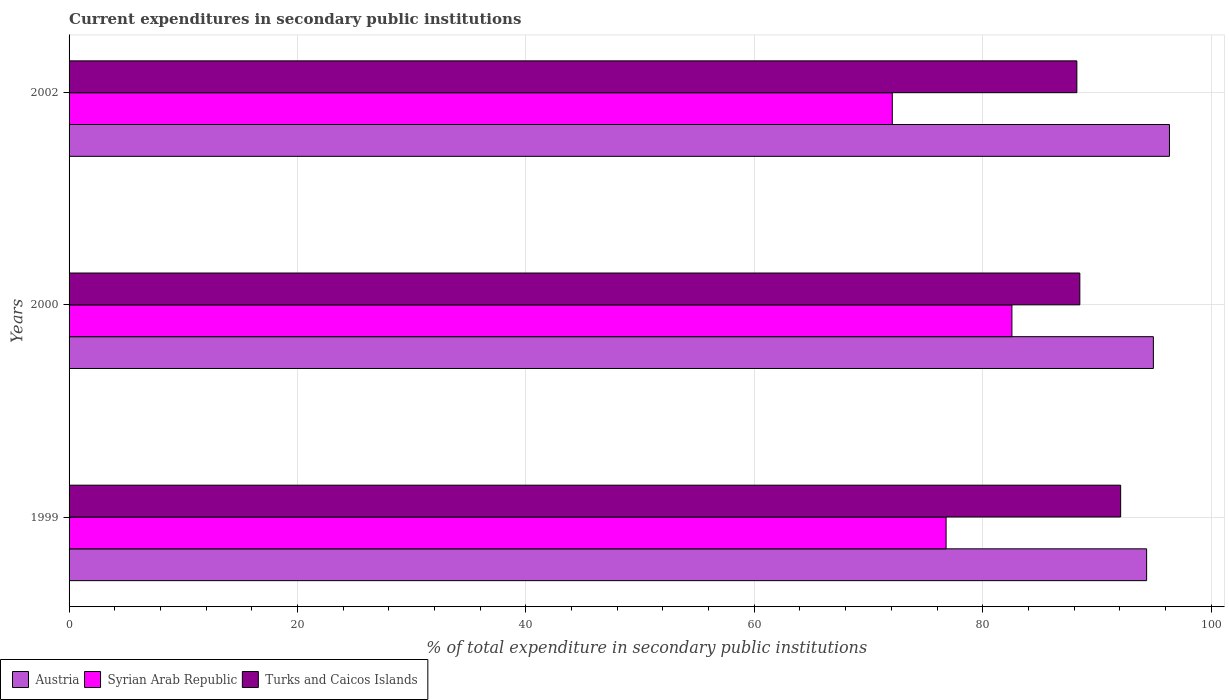How many different coloured bars are there?
Give a very brief answer. 3. How many groups of bars are there?
Make the answer very short. 3. Are the number of bars per tick equal to the number of legend labels?
Offer a very short reply. Yes. How many bars are there on the 3rd tick from the bottom?
Provide a short and direct response. 3. In how many cases, is the number of bars for a given year not equal to the number of legend labels?
Offer a terse response. 0. What is the current expenditures in secondary public institutions in Syrian Arab Republic in 2002?
Make the answer very short. 72.08. Across all years, what is the maximum current expenditures in secondary public institutions in Syrian Arab Republic?
Your answer should be compact. 82.56. Across all years, what is the minimum current expenditures in secondary public institutions in Turks and Caicos Islands?
Keep it short and to the point. 88.24. In which year was the current expenditures in secondary public institutions in Syrian Arab Republic maximum?
Your response must be concise. 2000. In which year was the current expenditures in secondary public institutions in Syrian Arab Republic minimum?
Offer a terse response. 2002. What is the total current expenditures in secondary public institutions in Austria in the graph?
Your response must be concise. 285.65. What is the difference between the current expenditures in secondary public institutions in Syrian Arab Republic in 1999 and that in 2000?
Make the answer very short. -5.76. What is the difference between the current expenditures in secondary public institutions in Turks and Caicos Islands in 2000 and the current expenditures in secondary public institutions in Syrian Arab Republic in 1999?
Ensure brevity in your answer.  11.71. What is the average current expenditures in secondary public institutions in Austria per year?
Give a very brief answer. 95.22. In the year 1999, what is the difference between the current expenditures in secondary public institutions in Syrian Arab Republic and current expenditures in secondary public institutions in Austria?
Keep it short and to the point. -17.56. In how many years, is the current expenditures in secondary public institutions in Austria greater than 84 %?
Ensure brevity in your answer.  3. What is the ratio of the current expenditures in secondary public institutions in Austria in 2000 to that in 2002?
Your answer should be very brief. 0.99. What is the difference between the highest and the second highest current expenditures in secondary public institutions in Syrian Arab Republic?
Your answer should be compact. 5.76. What is the difference between the highest and the lowest current expenditures in secondary public institutions in Austria?
Give a very brief answer. 2. In how many years, is the current expenditures in secondary public institutions in Syrian Arab Republic greater than the average current expenditures in secondary public institutions in Syrian Arab Republic taken over all years?
Your answer should be compact. 1. What does the 3rd bar from the bottom in 2000 represents?
Keep it short and to the point. Turks and Caicos Islands. Are all the bars in the graph horizontal?
Your answer should be compact. Yes. How many years are there in the graph?
Ensure brevity in your answer.  3. Are the values on the major ticks of X-axis written in scientific E-notation?
Offer a very short reply. No. Does the graph contain any zero values?
Make the answer very short. No. How many legend labels are there?
Offer a terse response. 3. How are the legend labels stacked?
Make the answer very short. Horizontal. What is the title of the graph?
Give a very brief answer. Current expenditures in secondary public institutions. What is the label or title of the X-axis?
Provide a succinct answer. % of total expenditure in secondary public institutions. What is the % of total expenditure in secondary public institutions of Austria in 1999?
Ensure brevity in your answer.  94.35. What is the % of total expenditure in secondary public institutions in Syrian Arab Republic in 1999?
Your response must be concise. 76.79. What is the % of total expenditure in secondary public institutions of Turks and Caicos Islands in 1999?
Give a very brief answer. 92.08. What is the % of total expenditure in secondary public institutions in Austria in 2000?
Your response must be concise. 94.94. What is the % of total expenditure in secondary public institutions of Syrian Arab Republic in 2000?
Offer a very short reply. 82.56. What is the % of total expenditure in secondary public institutions in Turks and Caicos Islands in 2000?
Give a very brief answer. 88.5. What is the % of total expenditure in secondary public institutions in Austria in 2002?
Offer a very short reply. 96.35. What is the % of total expenditure in secondary public institutions in Syrian Arab Republic in 2002?
Provide a short and direct response. 72.08. What is the % of total expenditure in secondary public institutions in Turks and Caicos Islands in 2002?
Offer a very short reply. 88.24. Across all years, what is the maximum % of total expenditure in secondary public institutions in Austria?
Provide a short and direct response. 96.35. Across all years, what is the maximum % of total expenditure in secondary public institutions in Syrian Arab Republic?
Ensure brevity in your answer.  82.56. Across all years, what is the maximum % of total expenditure in secondary public institutions in Turks and Caicos Islands?
Provide a short and direct response. 92.08. Across all years, what is the minimum % of total expenditure in secondary public institutions of Austria?
Provide a succinct answer. 94.35. Across all years, what is the minimum % of total expenditure in secondary public institutions of Syrian Arab Republic?
Keep it short and to the point. 72.08. Across all years, what is the minimum % of total expenditure in secondary public institutions of Turks and Caicos Islands?
Offer a terse response. 88.24. What is the total % of total expenditure in secondary public institutions in Austria in the graph?
Offer a terse response. 285.65. What is the total % of total expenditure in secondary public institutions in Syrian Arab Republic in the graph?
Offer a terse response. 231.43. What is the total % of total expenditure in secondary public institutions of Turks and Caicos Islands in the graph?
Offer a terse response. 268.82. What is the difference between the % of total expenditure in secondary public institutions in Austria in 1999 and that in 2000?
Ensure brevity in your answer.  -0.59. What is the difference between the % of total expenditure in secondary public institutions in Syrian Arab Republic in 1999 and that in 2000?
Give a very brief answer. -5.76. What is the difference between the % of total expenditure in secondary public institutions of Turks and Caicos Islands in 1999 and that in 2000?
Provide a succinct answer. 3.57. What is the difference between the % of total expenditure in secondary public institutions of Austria in 1999 and that in 2002?
Keep it short and to the point. -2. What is the difference between the % of total expenditure in secondary public institutions in Syrian Arab Republic in 1999 and that in 2002?
Give a very brief answer. 4.71. What is the difference between the % of total expenditure in secondary public institutions of Turks and Caicos Islands in 1999 and that in 2002?
Offer a terse response. 3.83. What is the difference between the % of total expenditure in secondary public institutions of Austria in 2000 and that in 2002?
Make the answer very short. -1.41. What is the difference between the % of total expenditure in secondary public institutions of Syrian Arab Republic in 2000 and that in 2002?
Ensure brevity in your answer.  10.48. What is the difference between the % of total expenditure in secondary public institutions of Turks and Caicos Islands in 2000 and that in 2002?
Ensure brevity in your answer.  0.26. What is the difference between the % of total expenditure in secondary public institutions of Austria in 1999 and the % of total expenditure in secondary public institutions of Syrian Arab Republic in 2000?
Give a very brief answer. 11.79. What is the difference between the % of total expenditure in secondary public institutions of Austria in 1999 and the % of total expenditure in secondary public institutions of Turks and Caicos Islands in 2000?
Your response must be concise. 5.85. What is the difference between the % of total expenditure in secondary public institutions in Syrian Arab Republic in 1999 and the % of total expenditure in secondary public institutions in Turks and Caicos Islands in 2000?
Your answer should be very brief. -11.71. What is the difference between the % of total expenditure in secondary public institutions of Austria in 1999 and the % of total expenditure in secondary public institutions of Syrian Arab Republic in 2002?
Offer a terse response. 22.27. What is the difference between the % of total expenditure in secondary public institutions in Austria in 1999 and the % of total expenditure in secondary public institutions in Turks and Caicos Islands in 2002?
Provide a succinct answer. 6.11. What is the difference between the % of total expenditure in secondary public institutions in Syrian Arab Republic in 1999 and the % of total expenditure in secondary public institutions in Turks and Caicos Islands in 2002?
Keep it short and to the point. -11.45. What is the difference between the % of total expenditure in secondary public institutions in Austria in 2000 and the % of total expenditure in secondary public institutions in Syrian Arab Republic in 2002?
Make the answer very short. 22.86. What is the difference between the % of total expenditure in secondary public institutions in Austria in 2000 and the % of total expenditure in secondary public institutions in Turks and Caicos Islands in 2002?
Give a very brief answer. 6.7. What is the difference between the % of total expenditure in secondary public institutions of Syrian Arab Republic in 2000 and the % of total expenditure in secondary public institutions of Turks and Caicos Islands in 2002?
Make the answer very short. -5.69. What is the average % of total expenditure in secondary public institutions in Austria per year?
Your response must be concise. 95.22. What is the average % of total expenditure in secondary public institutions of Syrian Arab Republic per year?
Keep it short and to the point. 77.14. What is the average % of total expenditure in secondary public institutions in Turks and Caicos Islands per year?
Provide a short and direct response. 89.61. In the year 1999, what is the difference between the % of total expenditure in secondary public institutions in Austria and % of total expenditure in secondary public institutions in Syrian Arab Republic?
Your response must be concise. 17.56. In the year 1999, what is the difference between the % of total expenditure in secondary public institutions of Austria and % of total expenditure in secondary public institutions of Turks and Caicos Islands?
Offer a very short reply. 2.27. In the year 1999, what is the difference between the % of total expenditure in secondary public institutions of Syrian Arab Republic and % of total expenditure in secondary public institutions of Turks and Caicos Islands?
Keep it short and to the point. -15.28. In the year 2000, what is the difference between the % of total expenditure in secondary public institutions in Austria and % of total expenditure in secondary public institutions in Syrian Arab Republic?
Give a very brief answer. 12.39. In the year 2000, what is the difference between the % of total expenditure in secondary public institutions of Austria and % of total expenditure in secondary public institutions of Turks and Caicos Islands?
Provide a short and direct response. 6.44. In the year 2000, what is the difference between the % of total expenditure in secondary public institutions of Syrian Arab Republic and % of total expenditure in secondary public institutions of Turks and Caicos Islands?
Your answer should be very brief. -5.95. In the year 2002, what is the difference between the % of total expenditure in secondary public institutions of Austria and % of total expenditure in secondary public institutions of Syrian Arab Republic?
Your answer should be compact. 24.27. In the year 2002, what is the difference between the % of total expenditure in secondary public institutions of Austria and % of total expenditure in secondary public institutions of Turks and Caicos Islands?
Make the answer very short. 8.11. In the year 2002, what is the difference between the % of total expenditure in secondary public institutions in Syrian Arab Republic and % of total expenditure in secondary public institutions in Turks and Caicos Islands?
Ensure brevity in your answer.  -16.16. What is the ratio of the % of total expenditure in secondary public institutions in Austria in 1999 to that in 2000?
Keep it short and to the point. 0.99. What is the ratio of the % of total expenditure in secondary public institutions in Syrian Arab Republic in 1999 to that in 2000?
Offer a very short reply. 0.93. What is the ratio of the % of total expenditure in secondary public institutions of Turks and Caicos Islands in 1999 to that in 2000?
Your answer should be very brief. 1.04. What is the ratio of the % of total expenditure in secondary public institutions in Austria in 1999 to that in 2002?
Offer a terse response. 0.98. What is the ratio of the % of total expenditure in secondary public institutions of Syrian Arab Republic in 1999 to that in 2002?
Keep it short and to the point. 1.07. What is the ratio of the % of total expenditure in secondary public institutions in Turks and Caicos Islands in 1999 to that in 2002?
Keep it short and to the point. 1.04. What is the ratio of the % of total expenditure in secondary public institutions of Austria in 2000 to that in 2002?
Give a very brief answer. 0.99. What is the ratio of the % of total expenditure in secondary public institutions of Syrian Arab Republic in 2000 to that in 2002?
Provide a succinct answer. 1.15. What is the difference between the highest and the second highest % of total expenditure in secondary public institutions in Austria?
Provide a succinct answer. 1.41. What is the difference between the highest and the second highest % of total expenditure in secondary public institutions in Syrian Arab Republic?
Your answer should be compact. 5.76. What is the difference between the highest and the second highest % of total expenditure in secondary public institutions of Turks and Caicos Islands?
Give a very brief answer. 3.57. What is the difference between the highest and the lowest % of total expenditure in secondary public institutions in Austria?
Give a very brief answer. 2. What is the difference between the highest and the lowest % of total expenditure in secondary public institutions in Syrian Arab Republic?
Provide a short and direct response. 10.48. What is the difference between the highest and the lowest % of total expenditure in secondary public institutions of Turks and Caicos Islands?
Keep it short and to the point. 3.83. 